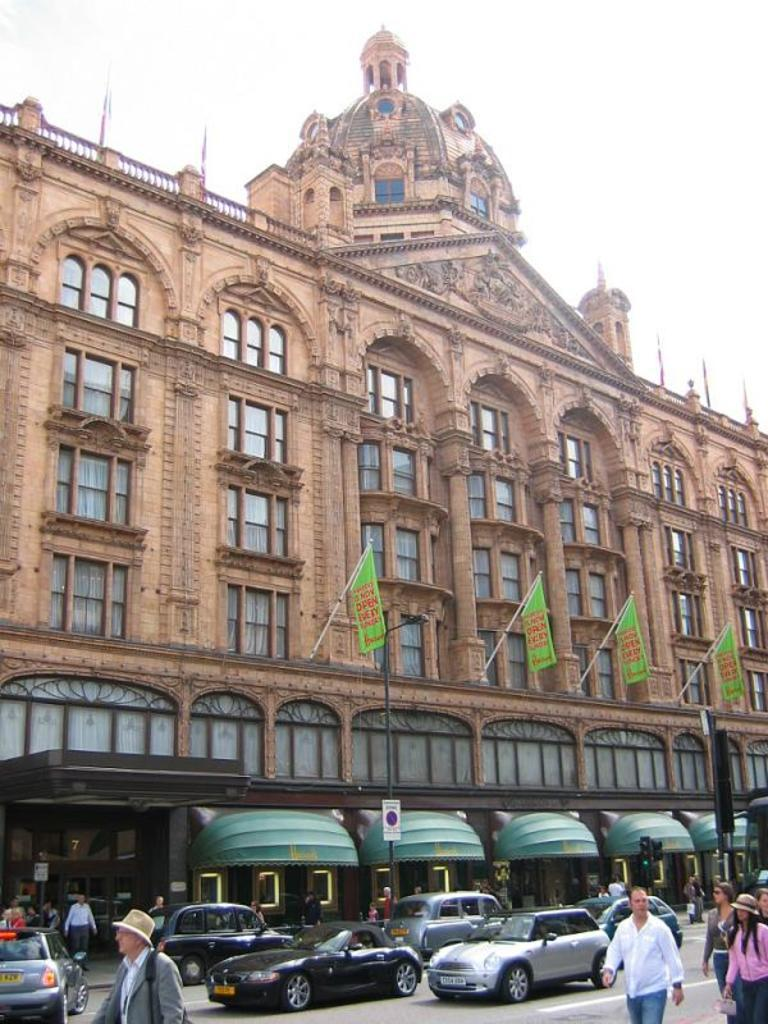What type of vehicles can be seen in the image? There are cars in the image. What are the people in the image doing? There are people walking on the road in the image. Can you describe the building in the image? There is a building with windows in the image. What is the purpose of the signboard in the image? The purpose of the signboard in the image is to provide information or directions. What can be seen flying in the image? There are flags in the image. How does the traffic signal light function in the image? The traffic signal light in the image regulates the flow of traffic. What is visible in the background of the image? The sky is visible in the background of the image. How many brothers are depicted in the image? There are no brothers present in the image. What type of teeth can be seen in the image? There are no teeth visible in the image. 